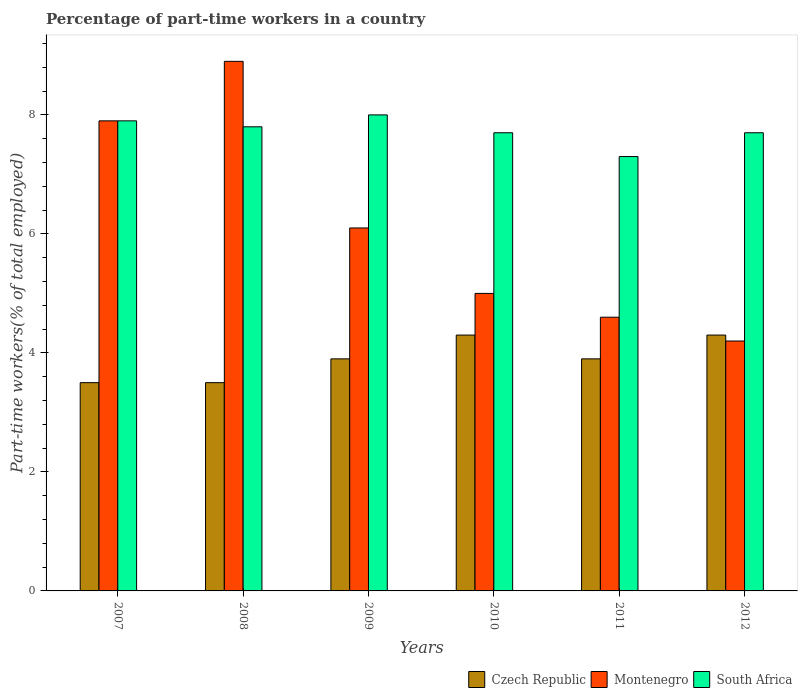Are the number of bars per tick equal to the number of legend labels?
Provide a succinct answer. Yes. Are the number of bars on each tick of the X-axis equal?
Your response must be concise. Yes. How many bars are there on the 4th tick from the left?
Provide a short and direct response. 3. How many bars are there on the 5th tick from the right?
Ensure brevity in your answer.  3. What is the percentage of part-time workers in Czech Republic in 2007?
Give a very brief answer. 3.5. Across all years, what is the maximum percentage of part-time workers in Czech Republic?
Ensure brevity in your answer.  4.3. Across all years, what is the minimum percentage of part-time workers in Czech Republic?
Offer a terse response. 3.5. In which year was the percentage of part-time workers in Montenegro maximum?
Your answer should be very brief. 2008. In which year was the percentage of part-time workers in Czech Republic minimum?
Your answer should be very brief. 2007. What is the total percentage of part-time workers in South Africa in the graph?
Provide a short and direct response. 46.4. What is the difference between the percentage of part-time workers in South Africa in 2007 and that in 2009?
Offer a terse response. -0.1. What is the difference between the percentage of part-time workers in South Africa in 2010 and the percentage of part-time workers in Montenegro in 2012?
Offer a terse response. 3.5. What is the average percentage of part-time workers in South Africa per year?
Your answer should be compact. 7.73. In the year 2011, what is the difference between the percentage of part-time workers in Czech Republic and percentage of part-time workers in Montenegro?
Give a very brief answer. -0.7. In how many years, is the percentage of part-time workers in Montenegro greater than 5.2 %?
Make the answer very short. 3. What is the ratio of the percentage of part-time workers in Montenegro in 2008 to that in 2010?
Give a very brief answer. 1.78. Is the difference between the percentage of part-time workers in Czech Republic in 2011 and 2012 greater than the difference between the percentage of part-time workers in Montenegro in 2011 and 2012?
Ensure brevity in your answer.  No. What is the difference between the highest and the second highest percentage of part-time workers in Czech Republic?
Ensure brevity in your answer.  0. What is the difference between the highest and the lowest percentage of part-time workers in South Africa?
Offer a terse response. 0.7. Is the sum of the percentage of part-time workers in Czech Republic in 2009 and 2012 greater than the maximum percentage of part-time workers in South Africa across all years?
Provide a succinct answer. Yes. What does the 3rd bar from the left in 2010 represents?
Keep it short and to the point. South Africa. What does the 1st bar from the right in 2012 represents?
Give a very brief answer. South Africa. Is it the case that in every year, the sum of the percentage of part-time workers in South Africa and percentage of part-time workers in Montenegro is greater than the percentage of part-time workers in Czech Republic?
Keep it short and to the point. Yes. How many bars are there?
Ensure brevity in your answer.  18. Are all the bars in the graph horizontal?
Your answer should be compact. No. Does the graph contain grids?
Your answer should be very brief. No. Where does the legend appear in the graph?
Your response must be concise. Bottom right. What is the title of the graph?
Ensure brevity in your answer.  Percentage of part-time workers in a country. Does "Uzbekistan" appear as one of the legend labels in the graph?
Provide a succinct answer. No. What is the label or title of the X-axis?
Keep it short and to the point. Years. What is the label or title of the Y-axis?
Provide a succinct answer. Part-time workers(% of total employed). What is the Part-time workers(% of total employed) of Czech Republic in 2007?
Give a very brief answer. 3.5. What is the Part-time workers(% of total employed) in Montenegro in 2007?
Your answer should be compact. 7.9. What is the Part-time workers(% of total employed) of South Africa in 2007?
Provide a short and direct response. 7.9. What is the Part-time workers(% of total employed) in Czech Republic in 2008?
Keep it short and to the point. 3.5. What is the Part-time workers(% of total employed) in Montenegro in 2008?
Make the answer very short. 8.9. What is the Part-time workers(% of total employed) in South Africa in 2008?
Make the answer very short. 7.8. What is the Part-time workers(% of total employed) of Czech Republic in 2009?
Make the answer very short. 3.9. What is the Part-time workers(% of total employed) of Montenegro in 2009?
Give a very brief answer. 6.1. What is the Part-time workers(% of total employed) in Czech Republic in 2010?
Give a very brief answer. 4.3. What is the Part-time workers(% of total employed) of Montenegro in 2010?
Offer a terse response. 5. What is the Part-time workers(% of total employed) in South Africa in 2010?
Ensure brevity in your answer.  7.7. What is the Part-time workers(% of total employed) in Czech Republic in 2011?
Offer a terse response. 3.9. What is the Part-time workers(% of total employed) of Montenegro in 2011?
Make the answer very short. 4.6. What is the Part-time workers(% of total employed) in South Africa in 2011?
Provide a short and direct response. 7.3. What is the Part-time workers(% of total employed) in Czech Republic in 2012?
Make the answer very short. 4.3. What is the Part-time workers(% of total employed) in Montenegro in 2012?
Your response must be concise. 4.2. What is the Part-time workers(% of total employed) of South Africa in 2012?
Offer a very short reply. 7.7. Across all years, what is the maximum Part-time workers(% of total employed) of Czech Republic?
Offer a very short reply. 4.3. Across all years, what is the maximum Part-time workers(% of total employed) in Montenegro?
Your answer should be compact. 8.9. Across all years, what is the maximum Part-time workers(% of total employed) of South Africa?
Keep it short and to the point. 8. Across all years, what is the minimum Part-time workers(% of total employed) of Czech Republic?
Your answer should be very brief. 3.5. Across all years, what is the minimum Part-time workers(% of total employed) in Montenegro?
Your answer should be very brief. 4.2. Across all years, what is the minimum Part-time workers(% of total employed) of South Africa?
Give a very brief answer. 7.3. What is the total Part-time workers(% of total employed) in Czech Republic in the graph?
Provide a short and direct response. 23.4. What is the total Part-time workers(% of total employed) in Montenegro in the graph?
Your response must be concise. 36.7. What is the total Part-time workers(% of total employed) of South Africa in the graph?
Keep it short and to the point. 46.4. What is the difference between the Part-time workers(% of total employed) of Czech Republic in 2007 and that in 2008?
Your response must be concise. 0. What is the difference between the Part-time workers(% of total employed) in South Africa in 2007 and that in 2008?
Keep it short and to the point. 0.1. What is the difference between the Part-time workers(% of total employed) of South Africa in 2007 and that in 2009?
Offer a terse response. -0.1. What is the difference between the Part-time workers(% of total employed) of South Africa in 2007 and that in 2010?
Ensure brevity in your answer.  0.2. What is the difference between the Part-time workers(% of total employed) of Czech Republic in 2007 and that in 2011?
Make the answer very short. -0.4. What is the difference between the Part-time workers(% of total employed) of Montenegro in 2007 and that in 2011?
Your response must be concise. 3.3. What is the difference between the Part-time workers(% of total employed) in South Africa in 2007 and that in 2011?
Your response must be concise. 0.6. What is the difference between the Part-time workers(% of total employed) of Czech Republic in 2007 and that in 2012?
Provide a short and direct response. -0.8. What is the difference between the Part-time workers(% of total employed) of South Africa in 2007 and that in 2012?
Your answer should be very brief. 0.2. What is the difference between the Part-time workers(% of total employed) in South Africa in 2008 and that in 2009?
Provide a short and direct response. -0.2. What is the difference between the Part-time workers(% of total employed) in Czech Republic in 2008 and that in 2011?
Make the answer very short. -0.4. What is the difference between the Part-time workers(% of total employed) in Montenegro in 2008 and that in 2011?
Give a very brief answer. 4.3. What is the difference between the Part-time workers(% of total employed) in South Africa in 2008 and that in 2011?
Your response must be concise. 0.5. What is the difference between the Part-time workers(% of total employed) of Czech Republic in 2008 and that in 2012?
Your response must be concise. -0.8. What is the difference between the Part-time workers(% of total employed) in Montenegro in 2009 and that in 2011?
Offer a very short reply. 1.5. What is the difference between the Part-time workers(% of total employed) of South Africa in 2009 and that in 2011?
Ensure brevity in your answer.  0.7. What is the difference between the Part-time workers(% of total employed) in Czech Republic in 2009 and that in 2012?
Ensure brevity in your answer.  -0.4. What is the difference between the Part-time workers(% of total employed) in South Africa in 2009 and that in 2012?
Your answer should be compact. 0.3. What is the difference between the Part-time workers(% of total employed) in Montenegro in 2010 and that in 2011?
Provide a succinct answer. 0.4. What is the difference between the Part-time workers(% of total employed) of South Africa in 2010 and that in 2011?
Offer a terse response. 0.4. What is the difference between the Part-time workers(% of total employed) of Montenegro in 2011 and that in 2012?
Provide a succinct answer. 0.4. What is the difference between the Part-time workers(% of total employed) in South Africa in 2011 and that in 2012?
Offer a very short reply. -0.4. What is the difference between the Part-time workers(% of total employed) in Czech Republic in 2007 and the Part-time workers(% of total employed) in South Africa in 2008?
Your answer should be compact. -4.3. What is the difference between the Part-time workers(% of total employed) in Czech Republic in 2007 and the Part-time workers(% of total employed) in South Africa in 2009?
Make the answer very short. -4.5. What is the difference between the Part-time workers(% of total employed) in Montenegro in 2007 and the Part-time workers(% of total employed) in South Africa in 2009?
Offer a terse response. -0.1. What is the difference between the Part-time workers(% of total employed) of Czech Republic in 2007 and the Part-time workers(% of total employed) of Montenegro in 2010?
Make the answer very short. -1.5. What is the difference between the Part-time workers(% of total employed) of Czech Republic in 2007 and the Part-time workers(% of total employed) of South Africa in 2010?
Your answer should be very brief. -4.2. What is the difference between the Part-time workers(% of total employed) in Montenegro in 2007 and the Part-time workers(% of total employed) in South Africa in 2010?
Keep it short and to the point. 0.2. What is the difference between the Part-time workers(% of total employed) of Czech Republic in 2008 and the Part-time workers(% of total employed) of Montenegro in 2009?
Keep it short and to the point. -2.6. What is the difference between the Part-time workers(% of total employed) in Czech Republic in 2008 and the Part-time workers(% of total employed) in South Africa in 2009?
Your answer should be very brief. -4.5. What is the difference between the Part-time workers(% of total employed) of Montenegro in 2008 and the Part-time workers(% of total employed) of South Africa in 2012?
Keep it short and to the point. 1.2. What is the difference between the Part-time workers(% of total employed) of Czech Republic in 2009 and the Part-time workers(% of total employed) of Montenegro in 2010?
Offer a terse response. -1.1. What is the difference between the Part-time workers(% of total employed) in Czech Republic in 2009 and the Part-time workers(% of total employed) in South Africa in 2010?
Your response must be concise. -3.8. What is the difference between the Part-time workers(% of total employed) of Montenegro in 2009 and the Part-time workers(% of total employed) of South Africa in 2010?
Provide a short and direct response. -1.6. What is the difference between the Part-time workers(% of total employed) of Czech Republic in 2009 and the Part-time workers(% of total employed) of Montenegro in 2011?
Ensure brevity in your answer.  -0.7. What is the difference between the Part-time workers(% of total employed) of Montenegro in 2009 and the Part-time workers(% of total employed) of South Africa in 2011?
Your answer should be compact. -1.2. What is the difference between the Part-time workers(% of total employed) in Czech Republic in 2010 and the Part-time workers(% of total employed) in Montenegro in 2011?
Provide a succinct answer. -0.3. What is the difference between the Part-time workers(% of total employed) of Montenegro in 2010 and the Part-time workers(% of total employed) of South Africa in 2011?
Give a very brief answer. -2.3. What is the difference between the Part-time workers(% of total employed) of Czech Republic in 2010 and the Part-time workers(% of total employed) of Montenegro in 2012?
Provide a succinct answer. 0.1. What is the difference between the Part-time workers(% of total employed) of Czech Republic in 2011 and the Part-time workers(% of total employed) of South Africa in 2012?
Your answer should be compact. -3.8. What is the difference between the Part-time workers(% of total employed) in Montenegro in 2011 and the Part-time workers(% of total employed) in South Africa in 2012?
Your response must be concise. -3.1. What is the average Part-time workers(% of total employed) of Czech Republic per year?
Your answer should be compact. 3.9. What is the average Part-time workers(% of total employed) of Montenegro per year?
Give a very brief answer. 6.12. What is the average Part-time workers(% of total employed) in South Africa per year?
Ensure brevity in your answer.  7.73. In the year 2007, what is the difference between the Part-time workers(% of total employed) in Czech Republic and Part-time workers(% of total employed) in Montenegro?
Your response must be concise. -4.4. In the year 2007, what is the difference between the Part-time workers(% of total employed) in Czech Republic and Part-time workers(% of total employed) in South Africa?
Offer a terse response. -4.4. In the year 2007, what is the difference between the Part-time workers(% of total employed) in Montenegro and Part-time workers(% of total employed) in South Africa?
Make the answer very short. 0. In the year 2008, what is the difference between the Part-time workers(% of total employed) of Czech Republic and Part-time workers(% of total employed) of Montenegro?
Give a very brief answer. -5.4. In the year 2009, what is the difference between the Part-time workers(% of total employed) in Montenegro and Part-time workers(% of total employed) in South Africa?
Make the answer very short. -1.9. In the year 2010, what is the difference between the Part-time workers(% of total employed) of Czech Republic and Part-time workers(% of total employed) of South Africa?
Your response must be concise. -3.4. In the year 2010, what is the difference between the Part-time workers(% of total employed) of Montenegro and Part-time workers(% of total employed) of South Africa?
Provide a succinct answer. -2.7. In the year 2012, what is the difference between the Part-time workers(% of total employed) in Czech Republic and Part-time workers(% of total employed) in Montenegro?
Ensure brevity in your answer.  0.1. In the year 2012, what is the difference between the Part-time workers(% of total employed) of Czech Republic and Part-time workers(% of total employed) of South Africa?
Your answer should be very brief. -3.4. In the year 2012, what is the difference between the Part-time workers(% of total employed) of Montenegro and Part-time workers(% of total employed) of South Africa?
Give a very brief answer. -3.5. What is the ratio of the Part-time workers(% of total employed) in Czech Republic in 2007 to that in 2008?
Offer a very short reply. 1. What is the ratio of the Part-time workers(% of total employed) of Montenegro in 2007 to that in 2008?
Keep it short and to the point. 0.89. What is the ratio of the Part-time workers(% of total employed) in South Africa in 2007 to that in 2008?
Provide a succinct answer. 1.01. What is the ratio of the Part-time workers(% of total employed) in Czech Republic in 2007 to that in 2009?
Make the answer very short. 0.9. What is the ratio of the Part-time workers(% of total employed) of Montenegro in 2007 to that in 2009?
Provide a short and direct response. 1.3. What is the ratio of the Part-time workers(% of total employed) in South Africa in 2007 to that in 2009?
Offer a terse response. 0.99. What is the ratio of the Part-time workers(% of total employed) in Czech Republic in 2007 to that in 2010?
Give a very brief answer. 0.81. What is the ratio of the Part-time workers(% of total employed) of Montenegro in 2007 to that in 2010?
Keep it short and to the point. 1.58. What is the ratio of the Part-time workers(% of total employed) of Czech Republic in 2007 to that in 2011?
Keep it short and to the point. 0.9. What is the ratio of the Part-time workers(% of total employed) of Montenegro in 2007 to that in 2011?
Provide a short and direct response. 1.72. What is the ratio of the Part-time workers(% of total employed) of South Africa in 2007 to that in 2011?
Keep it short and to the point. 1.08. What is the ratio of the Part-time workers(% of total employed) of Czech Republic in 2007 to that in 2012?
Give a very brief answer. 0.81. What is the ratio of the Part-time workers(% of total employed) in Montenegro in 2007 to that in 2012?
Offer a terse response. 1.88. What is the ratio of the Part-time workers(% of total employed) in Czech Republic in 2008 to that in 2009?
Your answer should be very brief. 0.9. What is the ratio of the Part-time workers(% of total employed) of Montenegro in 2008 to that in 2009?
Your answer should be compact. 1.46. What is the ratio of the Part-time workers(% of total employed) in South Africa in 2008 to that in 2009?
Provide a short and direct response. 0.97. What is the ratio of the Part-time workers(% of total employed) of Czech Republic in 2008 to that in 2010?
Provide a succinct answer. 0.81. What is the ratio of the Part-time workers(% of total employed) in Montenegro in 2008 to that in 2010?
Offer a terse response. 1.78. What is the ratio of the Part-time workers(% of total employed) of South Africa in 2008 to that in 2010?
Offer a very short reply. 1.01. What is the ratio of the Part-time workers(% of total employed) in Czech Republic in 2008 to that in 2011?
Your answer should be very brief. 0.9. What is the ratio of the Part-time workers(% of total employed) of Montenegro in 2008 to that in 2011?
Offer a very short reply. 1.93. What is the ratio of the Part-time workers(% of total employed) of South Africa in 2008 to that in 2011?
Ensure brevity in your answer.  1.07. What is the ratio of the Part-time workers(% of total employed) in Czech Republic in 2008 to that in 2012?
Your response must be concise. 0.81. What is the ratio of the Part-time workers(% of total employed) of Montenegro in 2008 to that in 2012?
Give a very brief answer. 2.12. What is the ratio of the Part-time workers(% of total employed) of South Africa in 2008 to that in 2012?
Ensure brevity in your answer.  1.01. What is the ratio of the Part-time workers(% of total employed) of Czech Republic in 2009 to that in 2010?
Provide a succinct answer. 0.91. What is the ratio of the Part-time workers(% of total employed) in Montenegro in 2009 to that in 2010?
Provide a short and direct response. 1.22. What is the ratio of the Part-time workers(% of total employed) in South Africa in 2009 to that in 2010?
Keep it short and to the point. 1.04. What is the ratio of the Part-time workers(% of total employed) in Montenegro in 2009 to that in 2011?
Give a very brief answer. 1.33. What is the ratio of the Part-time workers(% of total employed) in South Africa in 2009 to that in 2011?
Keep it short and to the point. 1.1. What is the ratio of the Part-time workers(% of total employed) of Czech Republic in 2009 to that in 2012?
Offer a very short reply. 0.91. What is the ratio of the Part-time workers(% of total employed) of Montenegro in 2009 to that in 2012?
Your answer should be very brief. 1.45. What is the ratio of the Part-time workers(% of total employed) of South Africa in 2009 to that in 2012?
Keep it short and to the point. 1.04. What is the ratio of the Part-time workers(% of total employed) of Czech Republic in 2010 to that in 2011?
Provide a short and direct response. 1.1. What is the ratio of the Part-time workers(% of total employed) in Montenegro in 2010 to that in 2011?
Give a very brief answer. 1.09. What is the ratio of the Part-time workers(% of total employed) of South Africa in 2010 to that in 2011?
Ensure brevity in your answer.  1.05. What is the ratio of the Part-time workers(% of total employed) in Montenegro in 2010 to that in 2012?
Offer a terse response. 1.19. What is the ratio of the Part-time workers(% of total employed) in Czech Republic in 2011 to that in 2012?
Keep it short and to the point. 0.91. What is the ratio of the Part-time workers(% of total employed) in Montenegro in 2011 to that in 2012?
Your answer should be compact. 1.1. What is the ratio of the Part-time workers(% of total employed) in South Africa in 2011 to that in 2012?
Offer a very short reply. 0.95. What is the difference between the highest and the second highest Part-time workers(% of total employed) in Montenegro?
Give a very brief answer. 1. What is the difference between the highest and the second highest Part-time workers(% of total employed) of South Africa?
Provide a succinct answer. 0.1. What is the difference between the highest and the lowest Part-time workers(% of total employed) of Czech Republic?
Ensure brevity in your answer.  0.8. What is the difference between the highest and the lowest Part-time workers(% of total employed) in South Africa?
Keep it short and to the point. 0.7. 